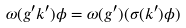Convert formula to latex. <formula><loc_0><loc_0><loc_500><loc_500>\omega ( g ^ { \prime } k ^ { \prime } ) \phi = \omega ( g ^ { \prime } ) ( \sigma ( k ^ { \prime } ) \phi )</formula> 